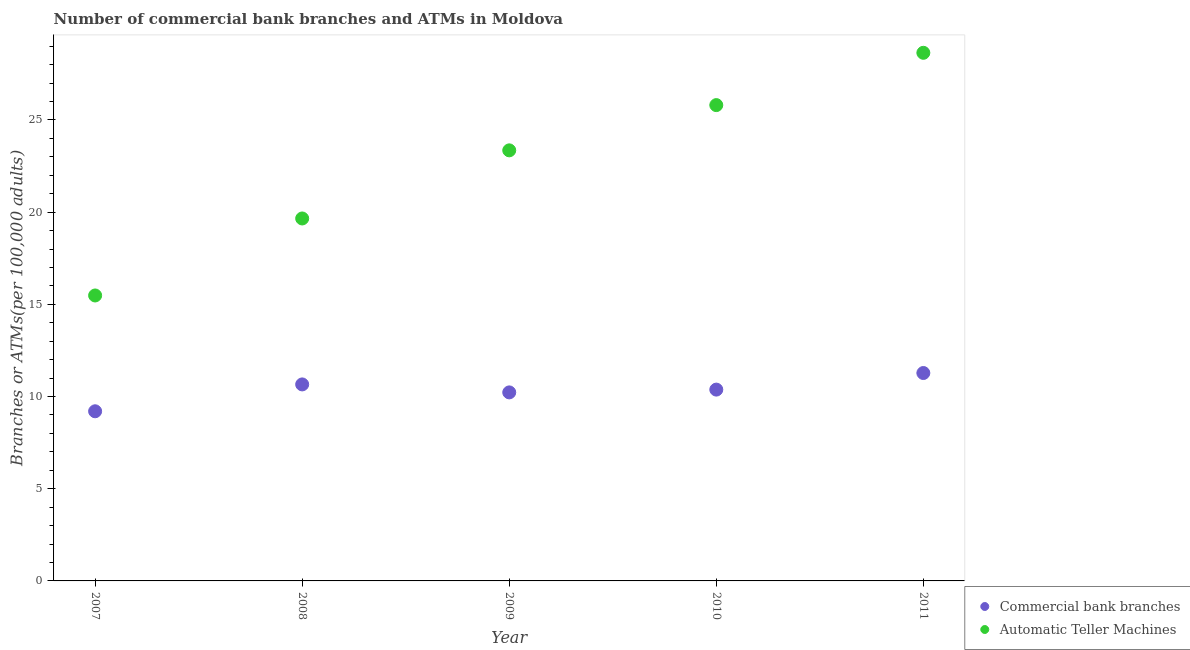Is the number of dotlines equal to the number of legend labels?
Your answer should be very brief. Yes. What is the number of atms in 2010?
Your response must be concise. 25.81. Across all years, what is the maximum number of atms?
Your answer should be compact. 28.64. Across all years, what is the minimum number of atms?
Give a very brief answer. 15.48. In which year was the number of atms maximum?
Make the answer very short. 2011. What is the total number of commercal bank branches in the graph?
Keep it short and to the point. 51.74. What is the difference between the number of atms in 2009 and that in 2010?
Your answer should be compact. -2.45. What is the difference between the number of atms in 2011 and the number of commercal bank branches in 2009?
Provide a short and direct response. 18.42. What is the average number of commercal bank branches per year?
Ensure brevity in your answer.  10.35. In the year 2009, what is the difference between the number of commercal bank branches and number of atms?
Your answer should be very brief. -13.13. What is the ratio of the number of atms in 2008 to that in 2009?
Keep it short and to the point. 0.84. Is the number of commercal bank branches in 2007 less than that in 2011?
Offer a very short reply. Yes. What is the difference between the highest and the second highest number of atms?
Your response must be concise. 2.84. What is the difference between the highest and the lowest number of atms?
Give a very brief answer. 13.16. Is the sum of the number of commercal bank branches in 2008 and 2010 greater than the maximum number of atms across all years?
Offer a very short reply. No. Is the number of commercal bank branches strictly greater than the number of atms over the years?
Your answer should be very brief. No. Is the number of commercal bank branches strictly less than the number of atms over the years?
Offer a terse response. Yes. Are the values on the major ticks of Y-axis written in scientific E-notation?
Provide a succinct answer. No. Does the graph contain any zero values?
Give a very brief answer. No. Where does the legend appear in the graph?
Your answer should be very brief. Bottom right. How are the legend labels stacked?
Your answer should be compact. Vertical. What is the title of the graph?
Offer a terse response. Number of commercial bank branches and ATMs in Moldova. What is the label or title of the Y-axis?
Your response must be concise. Branches or ATMs(per 100,0 adults). What is the Branches or ATMs(per 100,000 adults) of Commercial bank branches in 2007?
Offer a very short reply. 9.2. What is the Branches or ATMs(per 100,000 adults) of Automatic Teller Machines in 2007?
Offer a terse response. 15.48. What is the Branches or ATMs(per 100,000 adults) in Commercial bank branches in 2008?
Provide a succinct answer. 10.66. What is the Branches or ATMs(per 100,000 adults) in Automatic Teller Machines in 2008?
Your answer should be compact. 19.66. What is the Branches or ATMs(per 100,000 adults) in Commercial bank branches in 2009?
Your answer should be very brief. 10.23. What is the Branches or ATMs(per 100,000 adults) of Automatic Teller Machines in 2009?
Your response must be concise. 23.35. What is the Branches or ATMs(per 100,000 adults) in Commercial bank branches in 2010?
Your answer should be compact. 10.38. What is the Branches or ATMs(per 100,000 adults) of Automatic Teller Machines in 2010?
Your answer should be very brief. 25.81. What is the Branches or ATMs(per 100,000 adults) of Commercial bank branches in 2011?
Your answer should be compact. 11.28. What is the Branches or ATMs(per 100,000 adults) of Automatic Teller Machines in 2011?
Your answer should be very brief. 28.64. Across all years, what is the maximum Branches or ATMs(per 100,000 adults) of Commercial bank branches?
Your answer should be very brief. 11.28. Across all years, what is the maximum Branches or ATMs(per 100,000 adults) of Automatic Teller Machines?
Provide a short and direct response. 28.64. Across all years, what is the minimum Branches or ATMs(per 100,000 adults) in Commercial bank branches?
Your answer should be compact. 9.2. Across all years, what is the minimum Branches or ATMs(per 100,000 adults) in Automatic Teller Machines?
Provide a succinct answer. 15.48. What is the total Branches or ATMs(per 100,000 adults) in Commercial bank branches in the graph?
Ensure brevity in your answer.  51.74. What is the total Branches or ATMs(per 100,000 adults) of Automatic Teller Machines in the graph?
Provide a short and direct response. 112.94. What is the difference between the Branches or ATMs(per 100,000 adults) in Commercial bank branches in 2007 and that in 2008?
Your response must be concise. -1.46. What is the difference between the Branches or ATMs(per 100,000 adults) in Automatic Teller Machines in 2007 and that in 2008?
Your answer should be very brief. -4.18. What is the difference between the Branches or ATMs(per 100,000 adults) in Commercial bank branches in 2007 and that in 2009?
Make the answer very short. -1.02. What is the difference between the Branches or ATMs(per 100,000 adults) in Automatic Teller Machines in 2007 and that in 2009?
Your answer should be compact. -7.87. What is the difference between the Branches or ATMs(per 100,000 adults) in Commercial bank branches in 2007 and that in 2010?
Provide a short and direct response. -1.18. What is the difference between the Branches or ATMs(per 100,000 adults) of Automatic Teller Machines in 2007 and that in 2010?
Your answer should be compact. -10.32. What is the difference between the Branches or ATMs(per 100,000 adults) in Commercial bank branches in 2007 and that in 2011?
Your answer should be compact. -2.07. What is the difference between the Branches or ATMs(per 100,000 adults) of Automatic Teller Machines in 2007 and that in 2011?
Make the answer very short. -13.16. What is the difference between the Branches or ATMs(per 100,000 adults) in Commercial bank branches in 2008 and that in 2009?
Offer a terse response. 0.43. What is the difference between the Branches or ATMs(per 100,000 adults) of Automatic Teller Machines in 2008 and that in 2009?
Ensure brevity in your answer.  -3.69. What is the difference between the Branches or ATMs(per 100,000 adults) in Commercial bank branches in 2008 and that in 2010?
Keep it short and to the point. 0.28. What is the difference between the Branches or ATMs(per 100,000 adults) in Automatic Teller Machines in 2008 and that in 2010?
Give a very brief answer. -6.15. What is the difference between the Branches or ATMs(per 100,000 adults) in Commercial bank branches in 2008 and that in 2011?
Your answer should be very brief. -0.62. What is the difference between the Branches or ATMs(per 100,000 adults) in Automatic Teller Machines in 2008 and that in 2011?
Offer a very short reply. -8.99. What is the difference between the Branches or ATMs(per 100,000 adults) of Commercial bank branches in 2009 and that in 2010?
Ensure brevity in your answer.  -0.15. What is the difference between the Branches or ATMs(per 100,000 adults) in Automatic Teller Machines in 2009 and that in 2010?
Make the answer very short. -2.45. What is the difference between the Branches or ATMs(per 100,000 adults) in Commercial bank branches in 2009 and that in 2011?
Your answer should be very brief. -1.05. What is the difference between the Branches or ATMs(per 100,000 adults) of Automatic Teller Machines in 2009 and that in 2011?
Make the answer very short. -5.29. What is the difference between the Branches or ATMs(per 100,000 adults) in Commercial bank branches in 2010 and that in 2011?
Ensure brevity in your answer.  -0.9. What is the difference between the Branches or ATMs(per 100,000 adults) in Automatic Teller Machines in 2010 and that in 2011?
Your response must be concise. -2.84. What is the difference between the Branches or ATMs(per 100,000 adults) in Commercial bank branches in 2007 and the Branches or ATMs(per 100,000 adults) in Automatic Teller Machines in 2008?
Ensure brevity in your answer.  -10.46. What is the difference between the Branches or ATMs(per 100,000 adults) of Commercial bank branches in 2007 and the Branches or ATMs(per 100,000 adults) of Automatic Teller Machines in 2009?
Your response must be concise. -14.15. What is the difference between the Branches or ATMs(per 100,000 adults) of Commercial bank branches in 2007 and the Branches or ATMs(per 100,000 adults) of Automatic Teller Machines in 2010?
Your response must be concise. -16.61. What is the difference between the Branches or ATMs(per 100,000 adults) of Commercial bank branches in 2007 and the Branches or ATMs(per 100,000 adults) of Automatic Teller Machines in 2011?
Your answer should be very brief. -19.44. What is the difference between the Branches or ATMs(per 100,000 adults) in Commercial bank branches in 2008 and the Branches or ATMs(per 100,000 adults) in Automatic Teller Machines in 2009?
Keep it short and to the point. -12.69. What is the difference between the Branches or ATMs(per 100,000 adults) of Commercial bank branches in 2008 and the Branches or ATMs(per 100,000 adults) of Automatic Teller Machines in 2010?
Provide a short and direct response. -15.15. What is the difference between the Branches or ATMs(per 100,000 adults) of Commercial bank branches in 2008 and the Branches or ATMs(per 100,000 adults) of Automatic Teller Machines in 2011?
Provide a succinct answer. -17.99. What is the difference between the Branches or ATMs(per 100,000 adults) in Commercial bank branches in 2009 and the Branches or ATMs(per 100,000 adults) in Automatic Teller Machines in 2010?
Offer a terse response. -15.58. What is the difference between the Branches or ATMs(per 100,000 adults) in Commercial bank branches in 2009 and the Branches or ATMs(per 100,000 adults) in Automatic Teller Machines in 2011?
Provide a short and direct response. -18.42. What is the difference between the Branches or ATMs(per 100,000 adults) of Commercial bank branches in 2010 and the Branches or ATMs(per 100,000 adults) of Automatic Teller Machines in 2011?
Your response must be concise. -18.27. What is the average Branches or ATMs(per 100,000 adults) in Commercial bank branches per year?
Provide a short and direct response. 10.35. What is the average Branches or ATMs(per 100,000 adults) in Automatic Teller Machines per year?
Provide a short and direct response. 22.59. In the year 2007, what is the difference between the Branches or ATMs(per 100,000 adults) in Commercial bank branches and Branches or ATMs(per 100,000 adults) in Automatic Teller Machines?
Offer a very short reply. -6.28. In the year 2008, what is the difference between the Branches or ATMs(per 100,000 adults) in Commercial bank branches and Branches or ATMs(per 100,000 adults) in Automatic Teller Machines?
Give a very brief answer. -9. In the year 2009, what is the difference between the Branches or ATMs(per 100,000 adults) of Commercial bank branches and Branches or ATMs(per 100,000 adults) of Automatic Teller Machines?
Your answer should be compact. -13.13. In the year 2010, what is the difference between the Branches or ATMs(per 100,000 adults) in Commercial bank branches and Branches or ATMs(per 100,000 adults) in Automatic Teller Machines?
Ensure brevity in your answer.  -15.43. In the year 2011, what is the difference between the Branches or ATMs(per 100,000 adults) of Commercial bank branches and Branches or ATMs(per 100,000 adults) of Automatic Teller Machines?
Ensure brevity in your answer.  -17.37. What is the ratio of the Branches or ATMs(per 100,000 adults) of Commercial bank branches in 2007 to that in 2008?
Make the answer very short. 0.86. What is the ratio of the Branches or ATMs(per 100,000 adults) of Automatic Teller Machines in 2007 to that in 2008?
Provide a short and direct response. 0.79. What is the ratio of the Branches or ATMs(per 100,000 adults) of Commercial bank branches in 2007 to that in 2009?
Provide a succinct answer. 0.9. What is the ratio of the Branches or ATMs(per 100,000 adults) in Automatic Teller Machines in 2007 to that in 2009?
Your answer should be compact. 0.66. What is the ratio of the Branches or ATMs(per 100,000 adults) in Commercial bank branches in 2007 to that in 2010?
Your response must be concise. 0.89. What is the ratio of the Branches or ATMs(per 100,000 adults) in Automatic Teller Machines in 2007 to that in 2010?
Offer a terse response. 0.6. What is the ratio of the Branches or ATMs(per 100,000 adults) of Commercial bank branches in 2007 to that in 2011?
Your response must be concise. 0.82. What is the ratio of the Branches or ATMs(per 100,000 adults) of Automatic Teller Machines in 2007 to that in 2011?
Your answer should be very brief. 0.54. What is the ratio of the Branches or ATMs(per 100,000 adults) of Commercial bank branches in 2008 to that in 2009?
Provide a succinct answer. 1.04. What is the ratio of the Branches or ATMs(per 100,000 adults) of Automatic Teller Machines in 2008 to that in 2009?
Your answer should be compact. 0.84. What is the ratio of the Branches or ATMs(per 100,000 adults) in Commercial bank branches in 2008 to that in 2010?
Provide a succinct answer. 1.03. What is the ratio of the Branches or ATMs(per 100,000 adults) in Automatic Teller Machines in 2008 to that in 2010?
Your response must be concise. 0.76. What is the ratio of the Branches or ATMs(per 100,000 adults) of Commercial bank branches in 2008 to that in 2011?
Keep it short and to the point. 0.95. What is the ratio of the Branches or ATMs(per 100,000 adults) of Automatic Teller Machines in 2008 to that in 2011?
Provide a succinct answer. 0.69. What is the ratio of the Branches or ATMs(per 100,000 adults) of Commercial bank branches in 2009 to that in 2010?
Your answer should be very brief. 0.99. What is the ratio of the Branches or ATMs(per 100,000 adults) of Automatic Teller Machines in 2009 to that in 2010?
Your answer should be compact. 0.9. What is the ratio of the Branches or ATMs(per 100,000 adults) in Commercial bank branches in 2009 to that in 2011?
Provide a short and direct response. 0.91. What is the ratio of the Branches or ATMs(per 100,000 adults) in Automatic Teller Machines in 2009 to that in 2011?
Your answer should be very brief. 0.82. What is the ratio of the Branches or ATMs(per 100,000 adults) of Commercial bank branches in 2010 to that in 2011?
Provide a succinct answer. 0.92. What is the ratio of the Branches or ATMs(per 100,000 adults) in Automatic Teller Machines in 2010 to that in 2011?
Keep it short and to the point. 0.9. What is the difference between the highest and the second highest Branches or ATMs(per 100,000 adults) in Commercial bank branches?
Provide a short and direct response. 0.62. What is the difference between the highest and the second highest Branches or ATMs(per 100,000 adults) of Automatic Teller Machines?
Your answer should be very brief. 2.84. What is the difference between the highest and the lowest Branches or ATMs(per 100,000 adults) in Commercial bank branches?
Offer a very short reply. 2.07. What is the difference between the highest and the lowest Branches or ATMs(per 100,000 adults) in Automatic Teller Machines?
Provide a short and direct response. 13.16. 